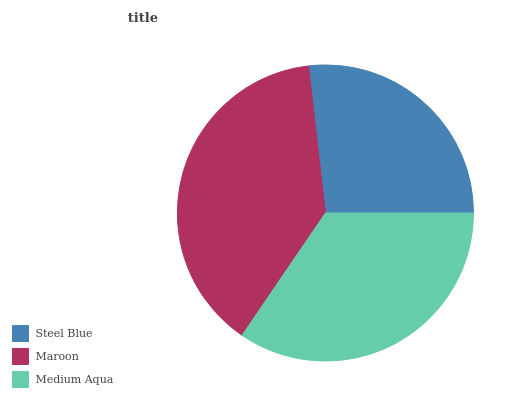Is Steel Blue the minimum?
Answer yes or no. Yes. Is Maroon the maximum?
Answer yes or no. Yes. Is Medium Aqua the minimum?
Answer yes or no. No. Is Medium Aqua the maximum?
Answer yes or no. No. Is Maroon greater than Medium Aqua?
Answer yes or no. Yes. Is Medium Aqua less than Maroon?
Answer yes or no. Yes. Is Medium Aqua greater than Maroon?
Answer yes or no. No. Is Maroon less than Medium Aqua?
Answer yes or no. No. Is Medium Aqua the high median?
Answer yes or no. Yes. Is Medium Aqua the low median?
Answer yes or no. Yes. Is Steel Blue the high median?
Answer yes or no. No. Is Steel Blue the low median?
Answer yes or no. No. 